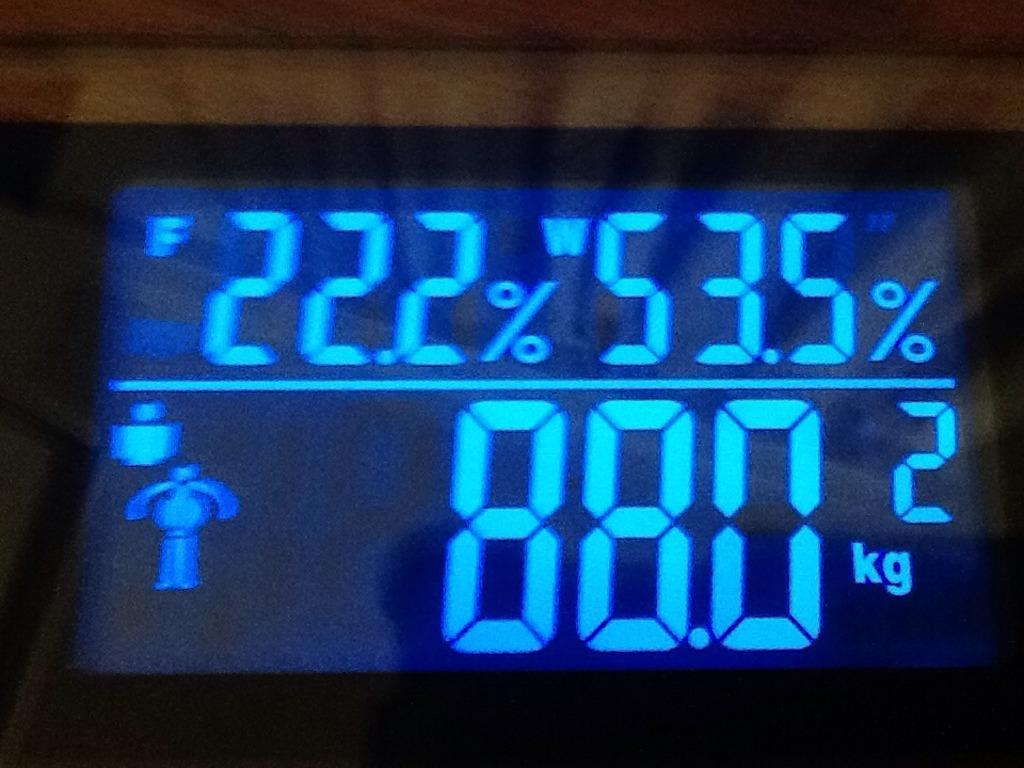Provide a one-sentence caption for the provided image. The display of a scale indicates that something weights 88 kilograms. 